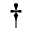<formula> <loc_0><loc_0><loc_500><loc_500>\dagger</formula> 